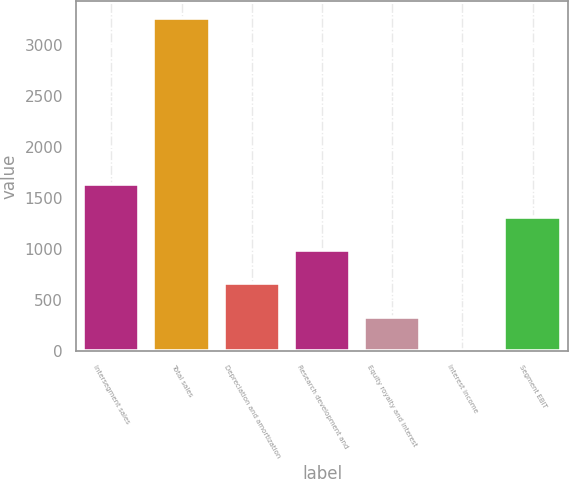Convert chart to OTSL. <chart><loc_0><loc_0><loc_500><loc_500><bar_chart><fcel>Intersegment sales<fcel>Total sales<fcel>Depreciation and amortization<fcel>Research development and<fcel>Equity royalty and interest<fcel>Interest income<fcel>Segment EBIT<nl><fcel>1638.5<fcel>3268<fcel>660.8<fcel>986.7<fcel>334.9<fcel>9<fcel>1312.6<nl></chart> 